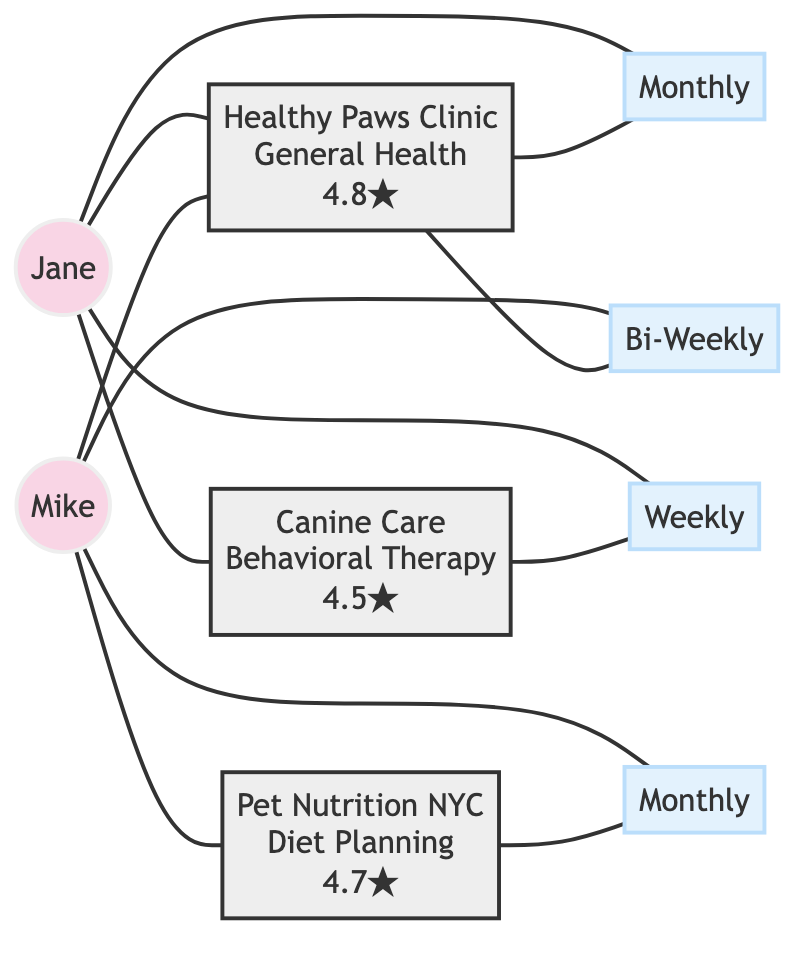What is the specialty of the Healthy Paws Clinic? The Healthy Paws Clinic is connected to the node that specifies its specialty. The node indicates it specializes in "General Health."
Answer: General Health How often does Jane visit Canine Care? Jane is linked to the Canine Care node through the frequency node, which indicates her visit frequency as "Weekly."
Answer: Weekly How many reviews does the Pet Nutrition NYC have? The Pet Nutrition NYC node shows the number of reviews as 4.7. This information can be directly extracted from the service node's ratings.
Answer: 4.7 Which pet owner visits the Healthy Paws Clinic bi-weekly? The connection between Pet Owner Mike and the frequency node indicates that Mike has a bi-weekly visit frequency specifically for the Healthy Paws Clinic.
Answer: Mike What is the relationship between Jane and the services offered in the diagram? Jane is connected to the Healthy Paws Clinic, Canine Care, and the corresponding frequency nodes, which indicates she utilizes multiple health services including a vet and a therapist.
Answer: Multiple How many total pet owners are represented in the diagram? By counting the pet owner nodes, there are two pet owners depicted in the diagram: Jane and Mike.
Answer: 2 Which pet owner has the highest frequency of visits? Analyzing the frequency connections indicates that Jane visits Canine Care weekly and the Healthy Paws Clinic monthly, while Mike's highest frequency is bi-weekly. Since weekly is more frequent than bi-weekly, Jane has the highest frequency.
Answer: Jane What type of services does Mike utilize? Mike is connected to the Healthy Paws Clinic and the Nutritionist Pet Nutrition NYC, indicating he utilizes these two services.
Answer: Two Services Which service has the lowest rating? By comparing the review ratings of each service node, the lowest rating appears under Canine Care at 4.5, as it is listed last in comparison to others (4.8 and 4.7).
Answer: 4.5 